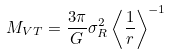<formula> <loc_0><loc_0><loc_500><loc_500>M _ { V T } = \frac { 3 \pi } { G } \sigma _ { R } ^ { 2 } \left \langle \frac { 1 } { r } \right \rangle ^ { - 1 }</formula> 